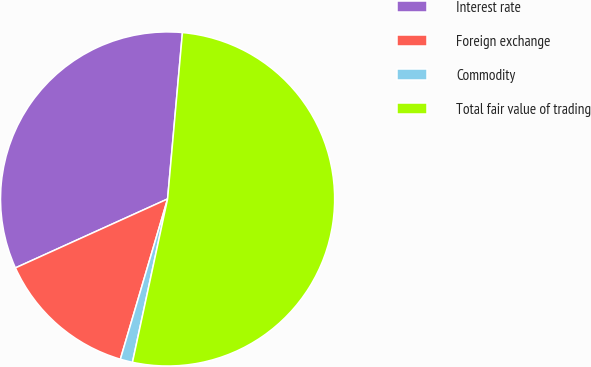Convert chart to OTSL. <chart><loc_0><loc_0><loc_500><loc_500><pie_chart><fcel>Interest rate<fcel>Foreign exchange<fcel>Commodity<fcel>Total fair value of trading<nl><fcel>33.19%<fcel>13.67%<fcel>1.19%<fcel>51.96%<nl></chart> 